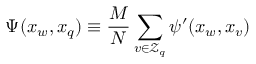<formula> <loc_0><loc_0><loc_500><loc_500>\Psi ( x _ { w } , x _ { q } ) \equiv \frac { M } { N } \sum _ { v \in \mathcal { Z } _ { q } } \psi ^ { \prime } ( x _ { w } , x _ { v } )</formula> 